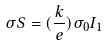<formula> <loc_0><loc_0><loc_500><loc_500>\sigma S = ( \frac { k } { e } ) \sigma _ { 0 } I _ { 1 }</formula> 